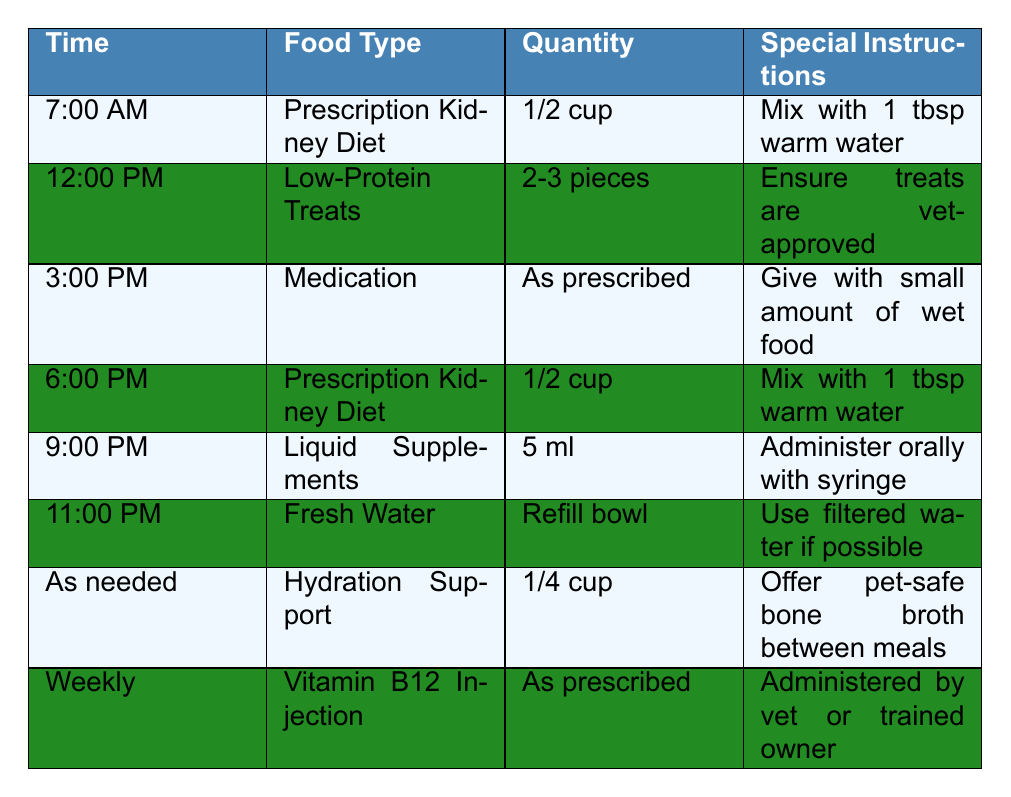What food is given at 7:00 AM? The table indicates that the food type given at 7:00 AM is "Prescription Kidney Diet."
Answer: Prescription Kidney Diet How many pieces of low-protein treats are given at noon? According to the table, 2-3 pieces of low-protein treats are provided at 12:00 PM.
Answer: 2-3 pieces What is mixed with the prescription kidney diet at breakfast and dinner? The table states that 1 tablespoon of warm water is mixed with the prescription kidney diet during breakfast (7:00 AM) and dinner (6:00 PM).
Answer: 1 tablespoon of warm water How much liquid supplement is administered at 9:00 PM? The table indicates that 5 ml of liquid supplements is administered at 9:00 PM.
Answer: 5 ml Is fresh water provided at 11:00 PM? Yes, the table confirms that fresh water is provided at 11:00 PM.
Answer: Yes What is the hydration support provided as needed? The table specifies that 1/4 cup of hydration support, which is pet-safe bone broth, is to be offered between meals as needed.
Answer: 1/4 cup of pet-safe bone broth What is the total amount of food provided daily (only including solid food)? The total includes 1/2 cup of prescription kidney diet at 7:00 AM and 6:00 PM, and 2-3 pieces of low-protein treats at 12:00 PM. Converting 1/2 cup to have a comparable measurement, it totals 1 cup of solid food + a treat estimated at 0.1 cup. Thus, the total is about 1.1 cups per day.
Answer: Approximately 1.1 cups Do any foods require special instructions? Yes, the table lists special instructions for every food entry, such as mixing food with water, ensuring veterinarian approval for treats, and administering medication in a specific way.
Answer: Yes What is the timeframe for the Vitamin B12 injection, and who administers it? According to the table, the Vitamin B12 injection is given weekly and can be administered by either the vet or a trained owner.
Answer: Weekly, administered by vet or trained owner Which food is provided immediately before and after the medication at 3:00 PM? Immediately before medication at 3:00 PM, there is no specific food listed, but wet food is used with the medication; however, prescription kidney diet is given at 7:00 AM and 6:00 PM. After, hydration support can be offered as needed.
Answer: Prescription kidney diet before, hydration support after 